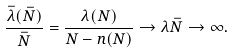Convert formula to latex. <formula><loc_0><loc_0><loc_500><loc_500>\frac { \bar { \lambda } ( \bar { N } ) } { \bar { N } } = \frac { \lambda ( N ) } { N - n ( N ) } \to \lambda \bar { N } \to \infty .</formula> 